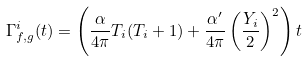Convert formula to latex. <formula><loc_0><loc_0><loc_500><loc_500>\Gamma ^ { i } _ { f , g } ( t ) = \left ( \frac { \alpha } { 4 \pi } T _ { i } ( T _ { i } + 1 ) + \frac { \alpha ^ { \prime } } { 4 \pi } \left ( \frac { Y _ { i } } { 2 } \right ) ^ { 2 } \right ) t</formula> 